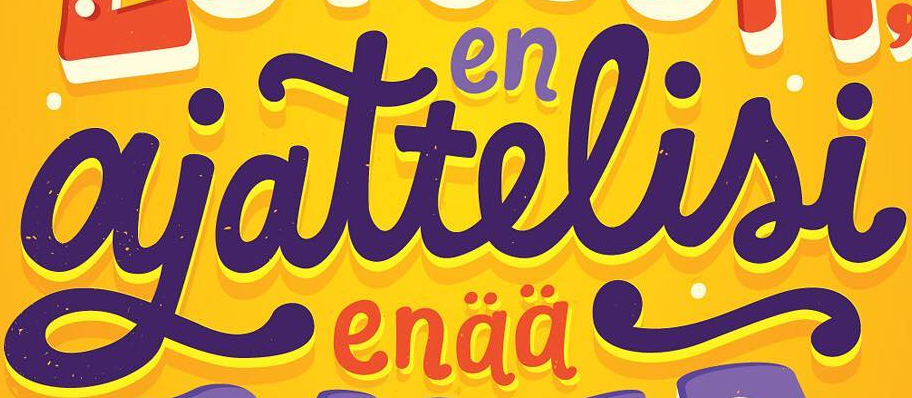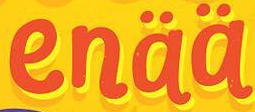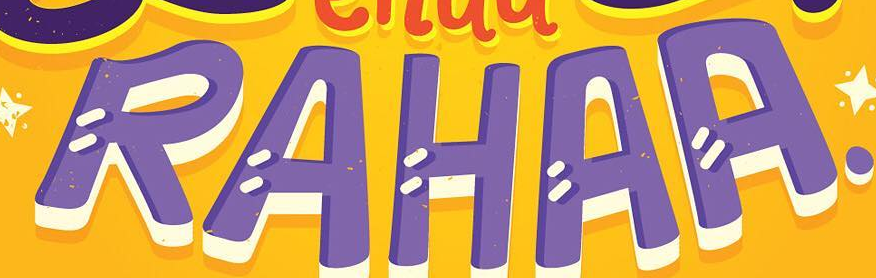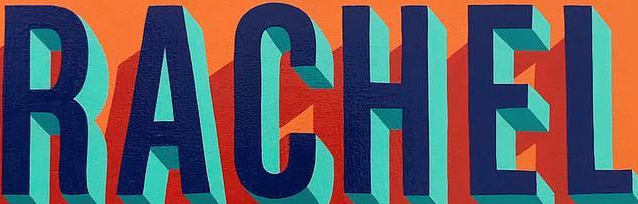Identify the words shown in these images in order, separated by a semicolon. ajattelisi; enää; RAHAA; RACHEL 